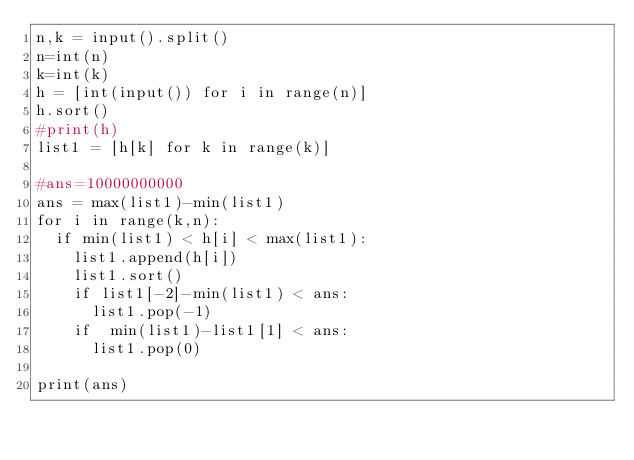<code> <loc_0><loc_0><loc_500><loc_500><_Python_>n,k = input().split()
n=int(n)
k=int(k)
h = [int(input()) for i in range(n)]
h.sort()
#print(h)
list1 = [h[k] for k in range(k)]

#ans=10000000000
ans = max(list1)-min(list1)
for i in range(k,n):
  if min(list1) < h[i] < max(list1):
    list1.append(h[i])
    list1.sort()
    if list1[-2]-min(list1) < ans:
      list1.pop(-1)
    if  min(list1)-list1[1] < ans:
      list1.pop(0)

print(ans)</code> 